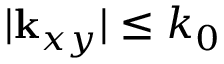<formula> <loc_0><loc_0><loc_500><loc_500>| { k } _ { x y } | \leq k _ { 0 }</formula> 